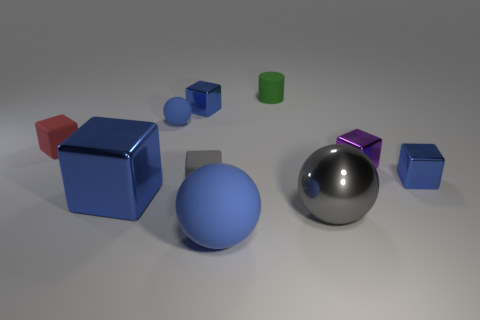Could you describe the lighting setup based on the shadows in the image? Absolutely, the shadows in the image are soft and diffuse, suggesting a light source that is not extremely close to the objects. The shadows extend mostly to the right of the objects, indicating the light is coming from the left side. Likely, the lighting resembles an overcast sky or a soft box in a studio, which is known to create such diffuse shadows and evenly distributed light. 